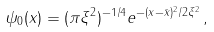Convert formula to latex. <formula><loc_0><loc_0><loc_500><loc_500>\psi _ { 0 } ( x ) = ( \pi \xi ^ { 2 } ) ^ { - 1 / 4 } e ^ { - ( x - \bar { x } ) ^ { 2 } / 2 \xi ^ { 2 } } \, ,</formula> 